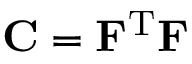Convert formula to latex. <formula><loc_0><loc_0><loc_500><loc_500>C = F ^ { T } F</formula> 